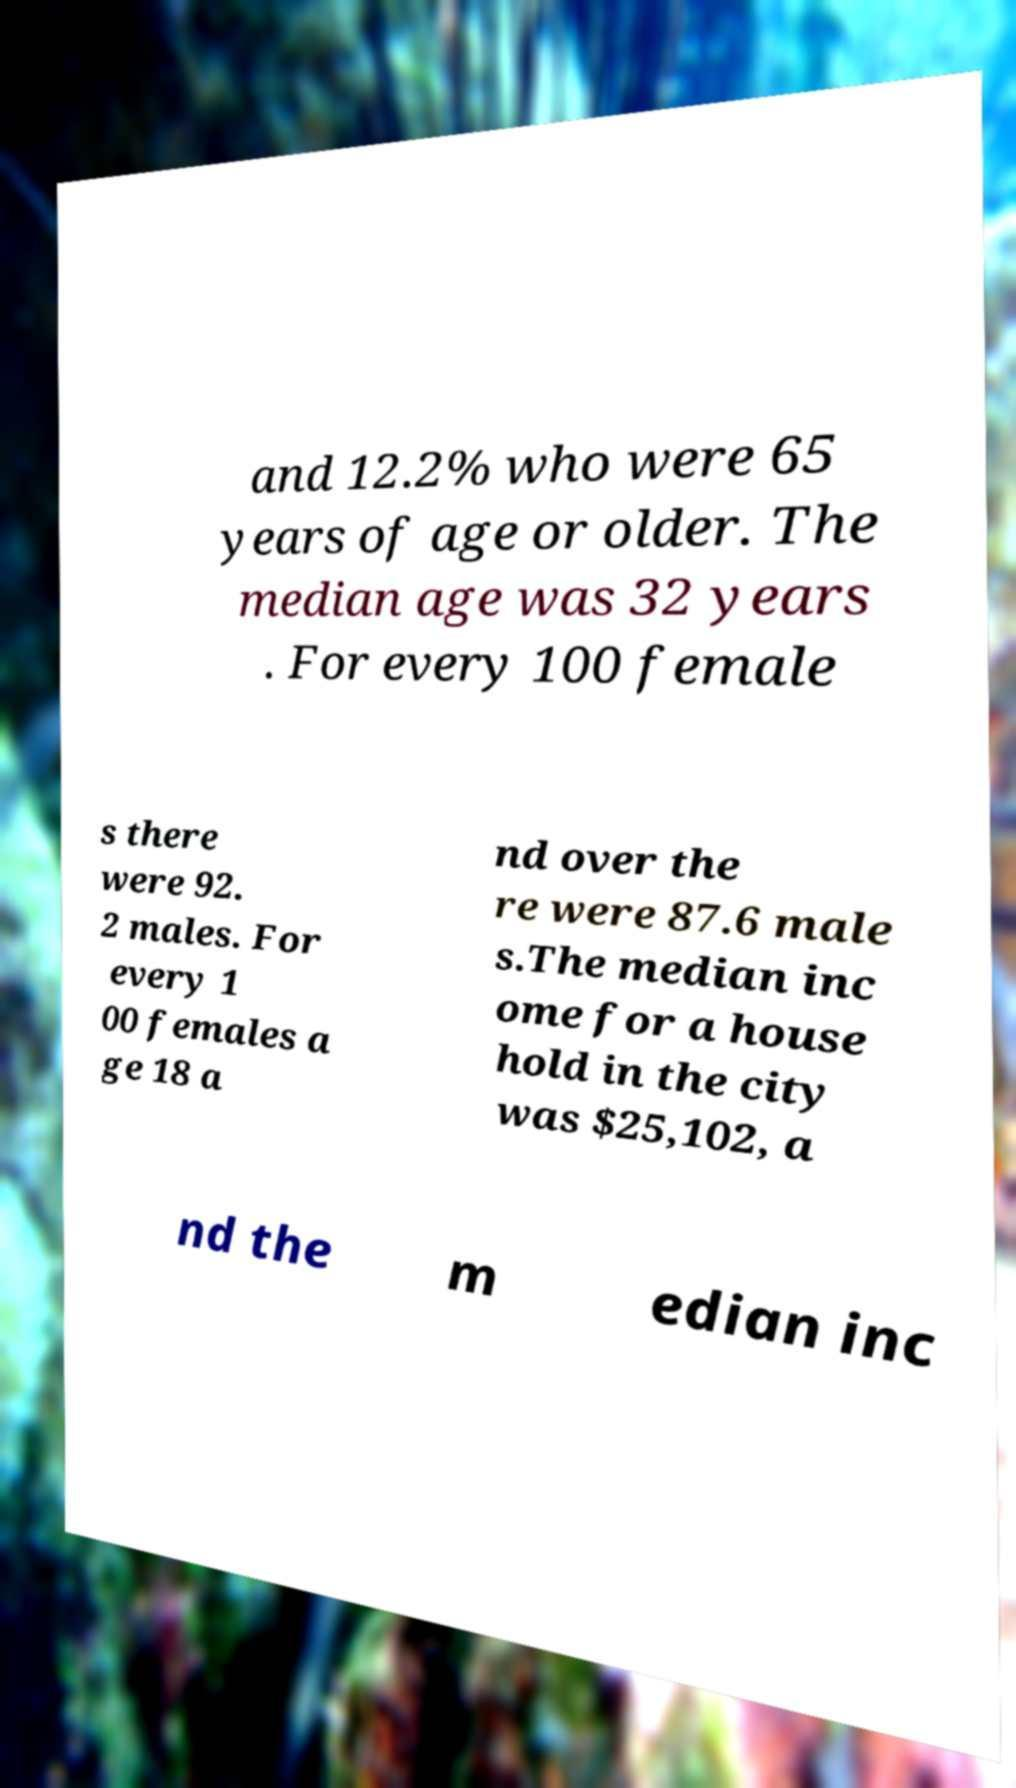Could you assist in decoding the text presented in this image and type it out clearly? and 12.2% who were 65 years of age or older. The median age was 32 years . For every 100 female s there were 92. 2 males. For every 1 00 females a ge 18 a nd over the re were 87.6 male s.The median inc ome for a house hold in the city was $25,102, a nd the m edian inc 